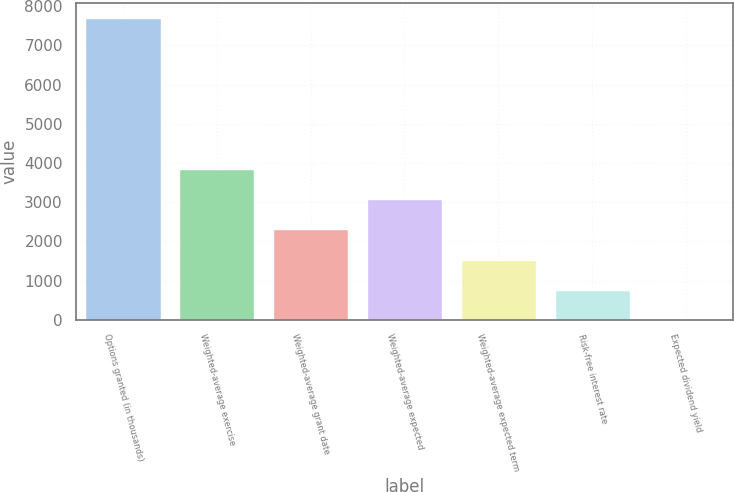Convert chart. <chart><loc_0><loc_0><loc_500><loc_500><bar_chart><fcel>Options granted (in thousands)<fcel>Weighted-average exercise<fcel>Weighted-average grant date<fcel>Weighted-average expected<fcel>Weighted-average expected term<fcel>Risk-free interest rate<fcel>Expected dividend yield<nl><fcel>7691<fcel>3846.6<fcel>2308.84<fcel>3077.72<fcel>1539.96<fcel>771.08<fcel>2.2<nl></chart> 